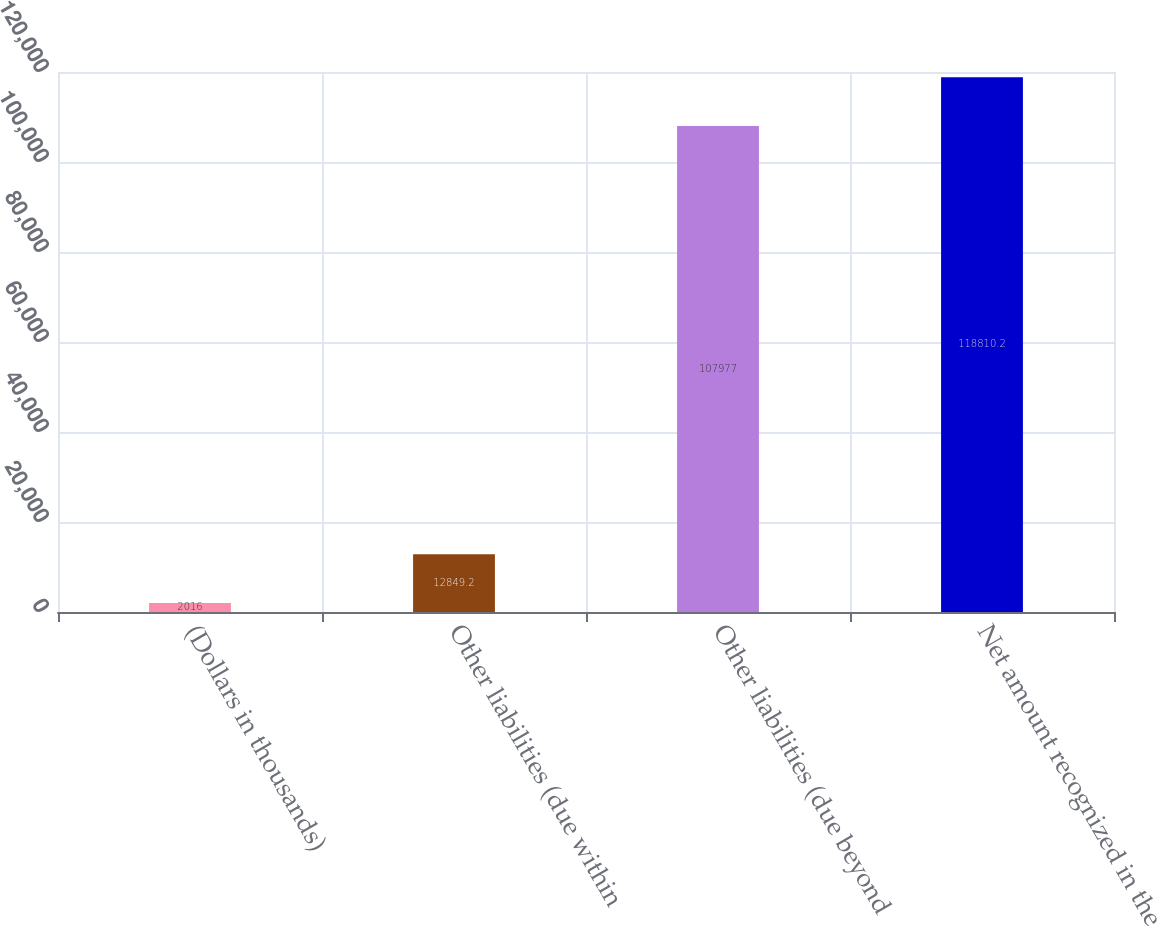Convert chart to OTSL. <chart><loc_0><loc_0><loc_500><loc_500><bar_chart><fcel>(Dollars in thousands)<fcel>Other liabilities (due within<fcel>Other liabilities (due beyond<fcel>Net amount recognized in the<nl><fcel>2016<fcel>12849.2<fcel>107977<fcel>118810<nl></chart> 